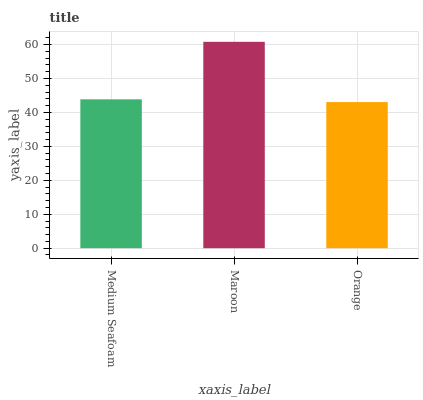Is Orange the minimum?
Answer yes or no. Yes. Is Maroon the maximum?
Answer yes or no. Yes. Is Maroon the minimum?
Answer yes or no. No. Is Orange the maximum?
Answer yes or no. No. Is Maroon greater than Orange?
Answer yes or no. Yes. Is Orange less than Maroon?
Answer yes or no. Yes. Is Orange greater than Maroon?
Answer yes or no. No. Is Maroon less than Orange?
Answer yes or no. No. Is Medium Seafoam the high median?
Answer yes or no. Yes. Is Medium Seafoam the low median?
Answer yes or no. Yes. Is Orange the high median?
Answer yes or no. No. Is Maroon the low median?
Answer yes or no. No. 